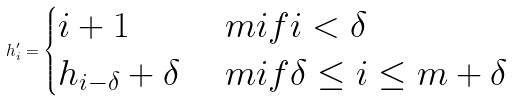<formula> <loc_0><loc_0><loc_500><loc_500>h ^ { \prime } _ { i } = \begin{cases} i + 1 & \ m i f i < \delta \\ h _ { i - \delta } + \delta & \ m i f \delta \leq i \leq m + \delta \end{cases}</formula> 